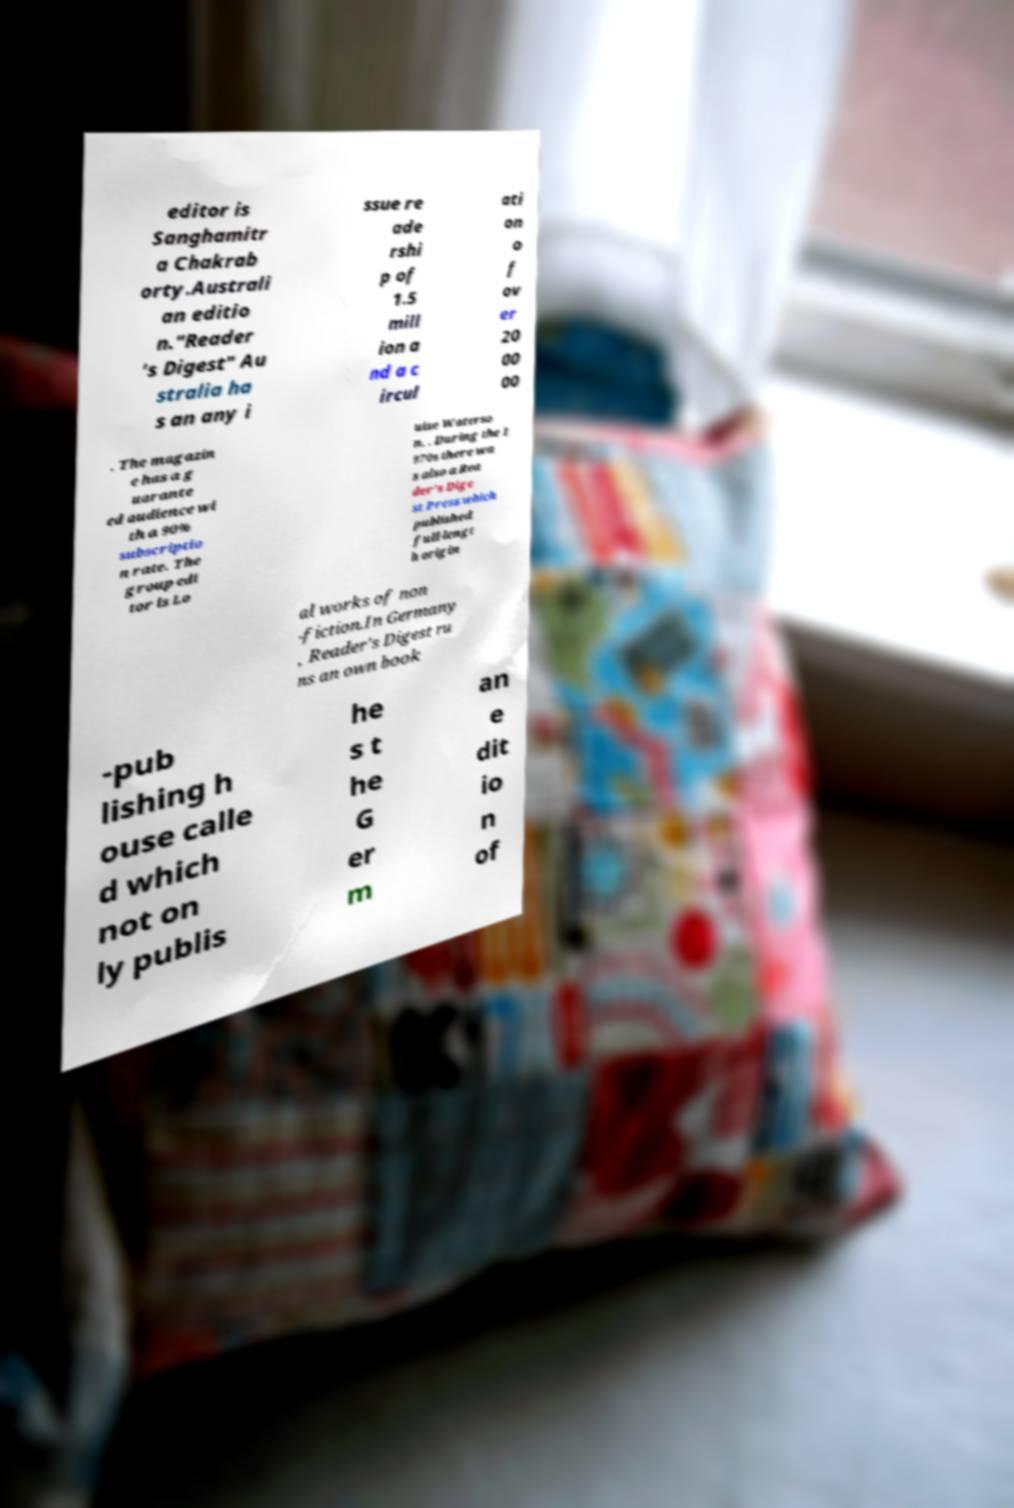What messages or text are displayed in this image? I need them in a readable, typed format. editor is Sanghamitr a Chakrab orty.Australi an editio n."Reader 's Digest" Au stralia ha s an any i ssue re ade rshi p of 1.5 mill ion a nd a c ircul ati on o f ov er 20 00 00 . The magazin e has a g uarante ed audience wi th a 90% subscriptio n rate. The group edi tor is Lo uise Waterso n. . During the 1 970s there wa s also a Rea der's Dige st Press which published full-lengt h origin al works of non -fiction.In Germany , Reader's Digest ru ns an own book -pub lishing h ouse calle d which not on ly publis he s t he G er m an e dit io n of 